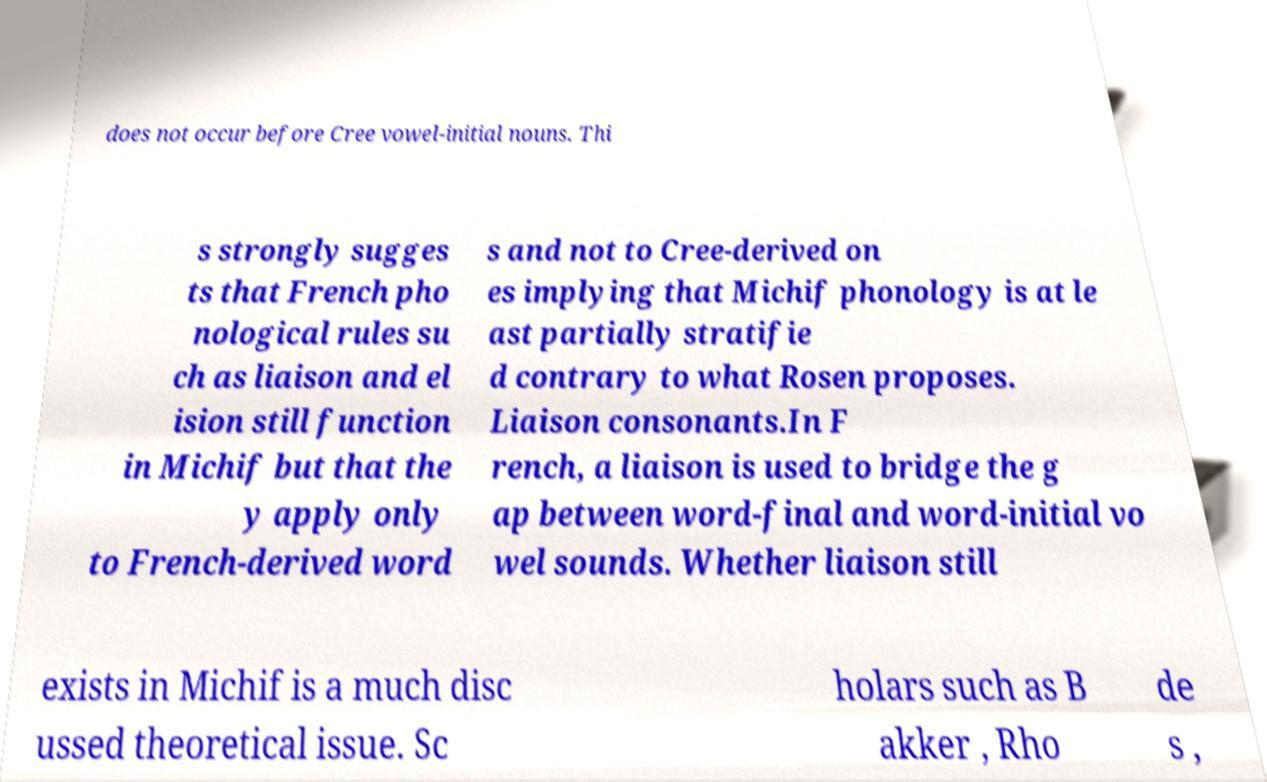Could you extract and type out the text from this image? does not occur before Cree vowel-initial nouns. Thi s strongly sugges ts that French pho nological rules su ch as liaison and el ision still function in Michif but that the y apply only to French-derived word s and not to Cree-derived on es implying that Michif phonology is at le ast partially stratifie d contrary to what Rosen proposes. Liaison consonants.In F rench, a liaison is used to bridge the g ap between word-final and word-initial vo wel sounds. Whether liaison still exists in Michif is a much disc ussed theoretical issue. Sc holars such as B akker , Rho de s , 